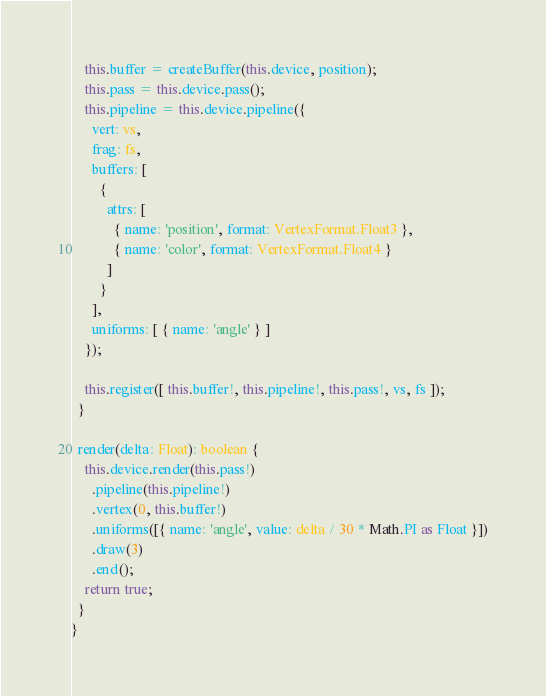Convert code to text. <code><loc_0><loc_0><loc_500><loc_500><_TypeScript_>    this.buffer = createBuffer(this.device, position);
    this.pass = this.device.pass();
    this.pipeline = this.device.pipeline({
      vert: vs,
      frag: fs,
      buffers: [
        {
          attrs: [
            { name: 'position', format: VertexFormat.Float3 },
            { name: 'color', format: VertexFormat.Float4 }
          ]
        }
      ],
      uniforms: [ { name: 'angle' } ]
    });

    this.register([ this.buffer!, this.pipeline!, this.pass!, vs, fs ]);
  }

  render(delta: Float): boolean {
    this.device.render(this.pass!)
      .pipeline(this.pipeline!)
      .vertex(0, this.buffer!)
      .uniforms([{ name: 'angle', value: delta / 30 * Math.PI as Float }])
      .draw(3)
      .end();
    return true;
  }
}
</code> 